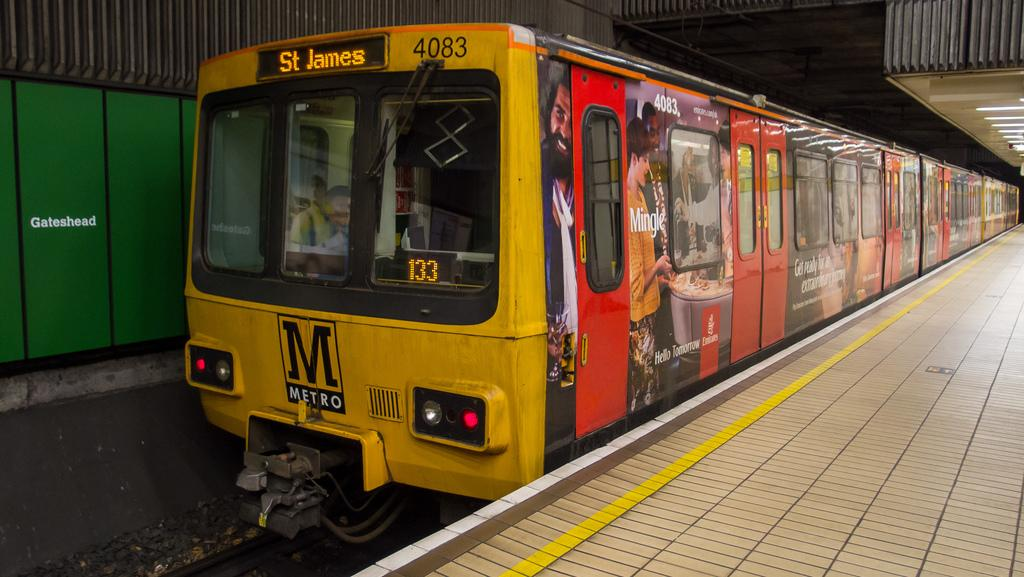What is the main subject of the image? The main subject of the image is a locomotive. What color is the locomotive? The locomotive is yellow in color. Where is the locomotive located in the image? The locomotive is on a platform. What is the material of the roof visible in the image? The roof is made of iron sheets. How many babies are playing with a match near the locomotive in the image? There are no babies or matches present in the image. 